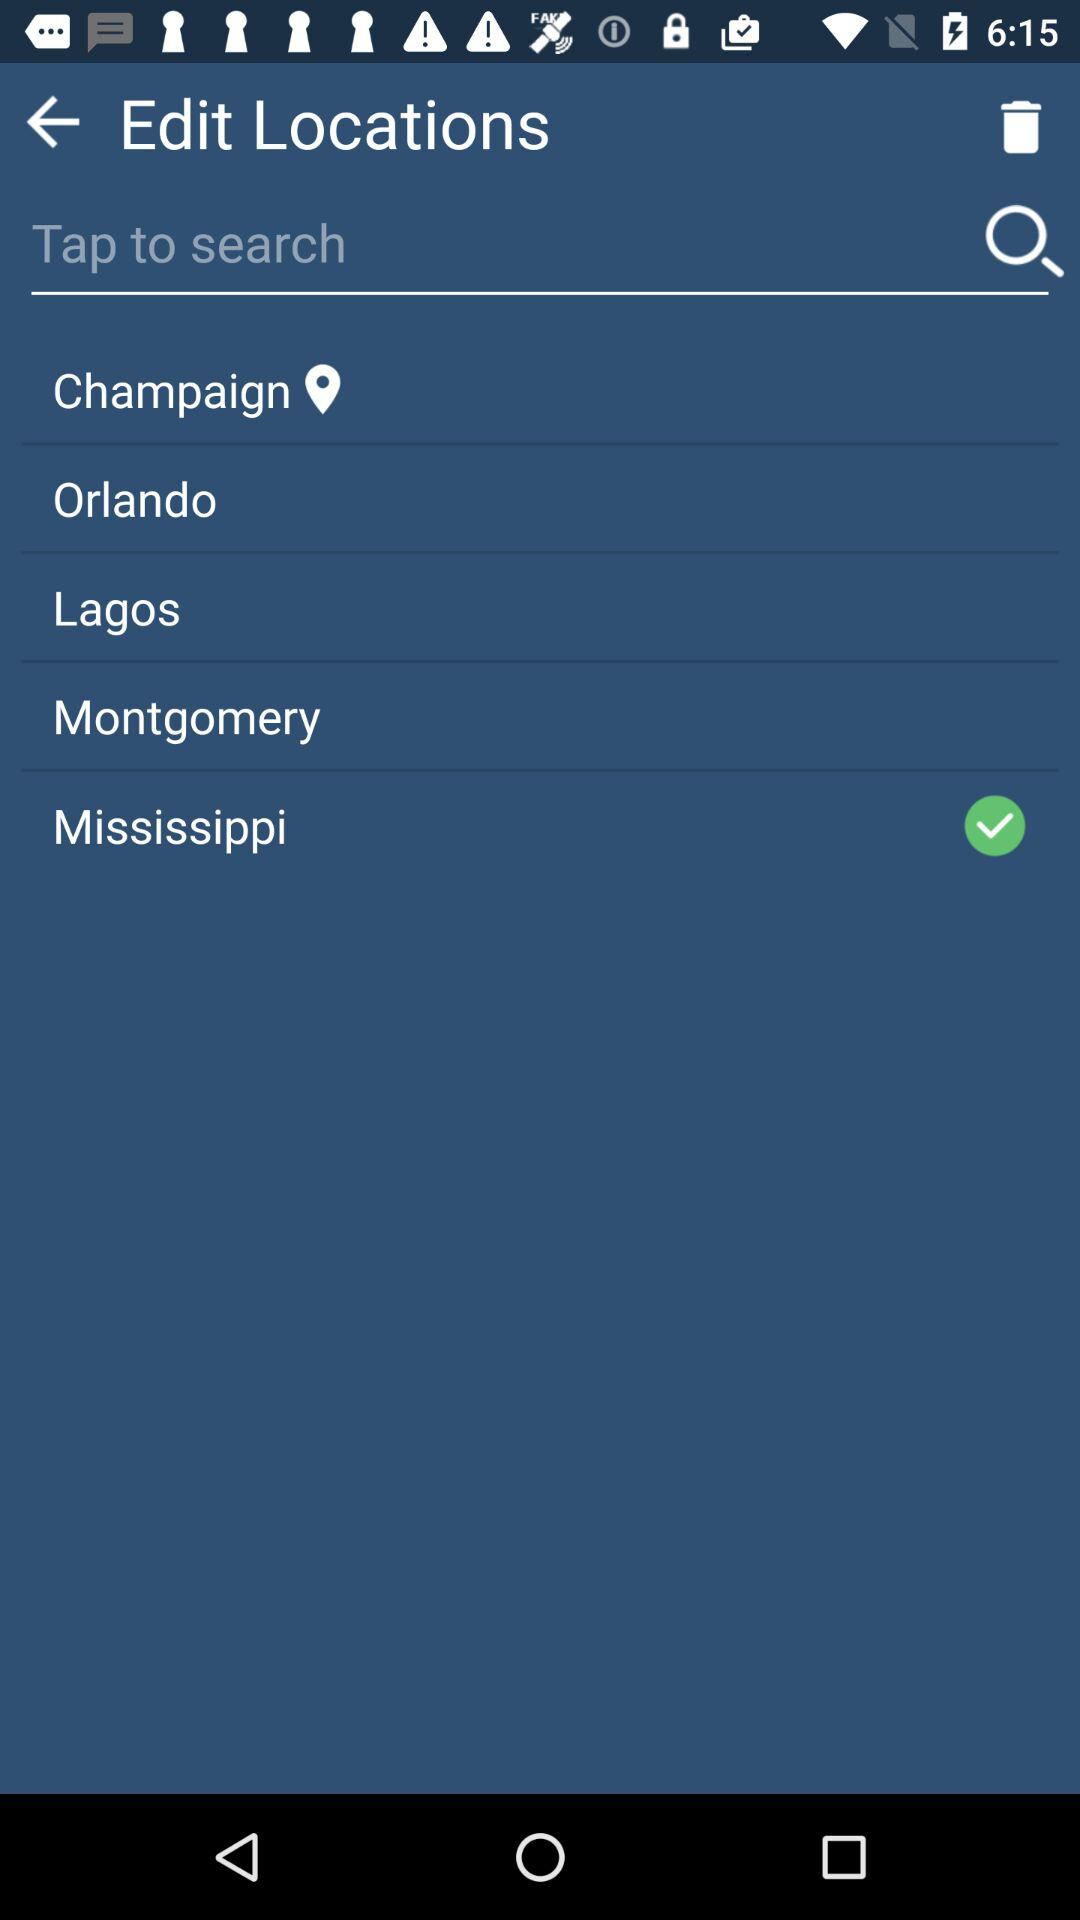What is the selected option? The selected option is "Mississippi". 